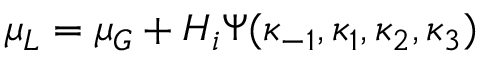Convert formula to latex. <formula><loc_0><loc_0><loc_500><loc_500>\mu _ { L } = \mu _ { G } + H _ { i } \Psi ( \kappa _ { - 1 } , \kappa _ { 1 } , \kappa _ { 2 } , \kappa _ { 3 } )</formula> 